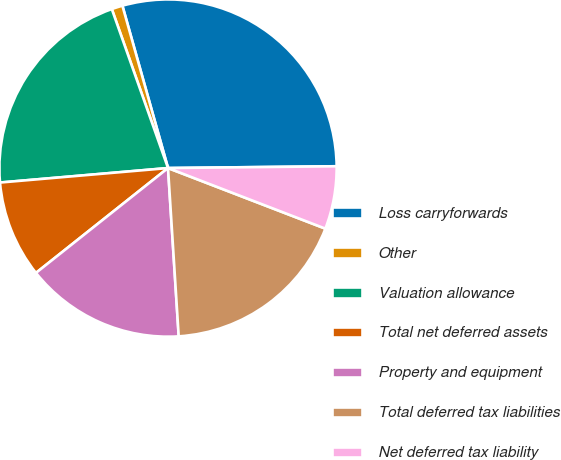Convert chart. <chart><loc_0><loc_0><loc_500><loc_500><pie_chart><fcel>Loss carryforwards<fcel>Other<fcel>Valuation allowance<fcel>Total net deferred assets<fcel>Property and equipment<fcel>Total deferred tax liabilities<fcel>Net deferred tax liability<nl><fcel>29.19%<fcel>1.05%<fcel>20.96%<fcel>9.31%<fcel>15.33%<fcel>18.14%<fcel>6.02%<nl></chart> 